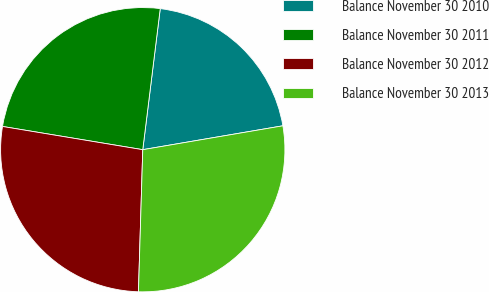Convert chart. <chart><loc_0><loc_0><loc_500><loc_500><pie_chart><fcel>Balance November 30 2010<fcel>Balance November 30 2011<fcel>Balance November 30 2012<fcel>Balance November 30 2013<nl><fcel>20.35%<fcel>24.35%<fcel>27.13%<fcel>28.17%<nl></chart> 